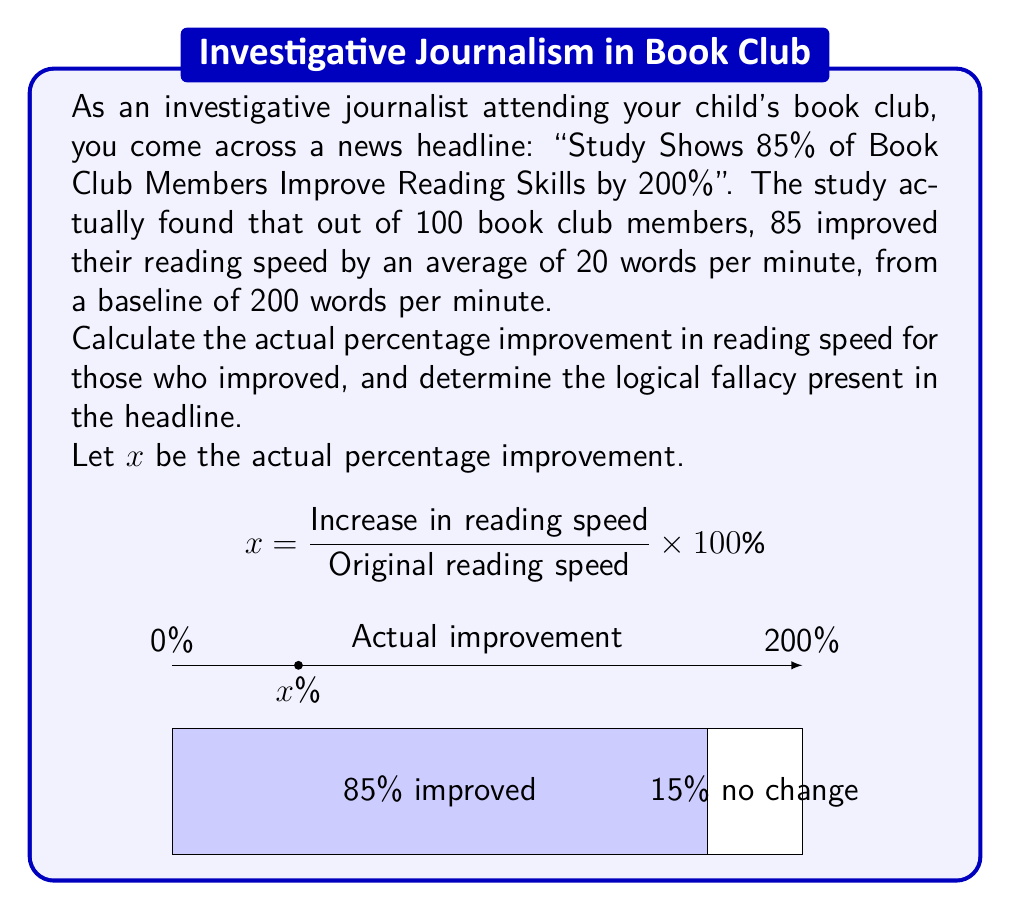Can you answer this question? Let's approach this step-by-step:

1) First, calculate the actual percentage improvement:
   
   Original reading speed = 200 words per minute
   Increase in reading speed = 20 words per minute

   $$x = \frac{20}{200} \times 100\% = 0.1 \times 100\% = 10\%$$

2) The actual improvement for those who improved their reading speed is 10%.

3) Now, let's identify the logical fallacies in the headline:

   a) Exaggeration: The headline claims a 200% improvement, which is far from the actual 10% improvement.
   
   b) Misleading statistics: The headline implies that 85% of members improved by 200%, when in reality, 85% of members improved by only 10%.
   
   c) Ambiguity: The headline doesn't specify what "improve reading skills" means, conflating reading speed with overall reading skills.

4) The main logical fallacy here is a combination of exaggeration and misleading statistics, often categorized as "cherry-picking" or "misrepresentation of data".

5) As an investigative journalist, it's crucial to recognize such fallacies to maintain journalistic integrity and accurately inform the public.
Answer: 10% actual improvement; Exaggeration and misleading statistics (cherry-picking) 